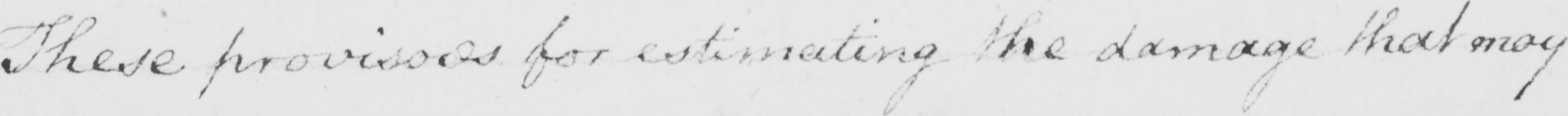Please transcribe the handwritten text in this image. These provisors for estimating the damage that may 